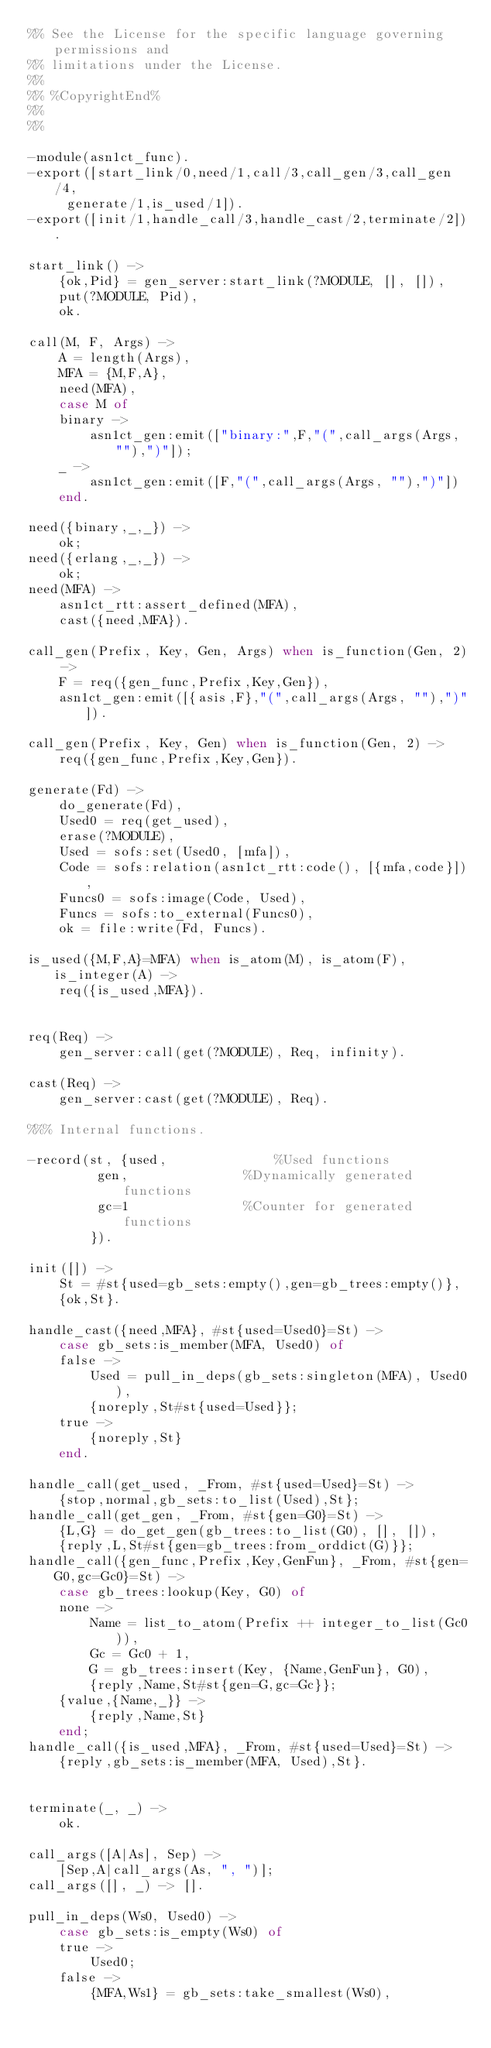Convert code to text. <code><loc_0><loc_0><loc_500><loc_500><_Erlang_>%% See the License for the specific language governing permissions and
%% limitations under the License.
%%
%% %CopyrightEnd%
%%
%%

-module(asn1ct_func).
-export([start_link/0,need/1,call/3,call_gen/3,call_gen/4,
	 generate/1,is_used/1]).
-export([init/1,handle_call/3,handle_cast/2,terminate/2]).

start_link() ->
    {ok,Pid} = gen_server:start_link(?MODULE, [], []),
    put(?MODULE, Pid),
    ok.

call(M, F, Args) ->
    A = length(Args),
    MFA = {M,F,A},
    need(MFA),
    case M of
	binary ->
	    asn1ct_gen:emit(["binary:",F,"(",call_args(Args, ""),")"]);
	_ ->
	    asn1ct_gen:emit([F,"(",call_args(Args, ""),")"])
    end.

need({binary,_,_}) ->
    ok;
need({erlang,_,_}) ->
    ok;
need(MFA) ->
    asn1ct_rtt:assert_defined(MFA),
    cast({need,MFA}).

call_gen(Prefix, Key, Gen, Args) when is_function(Gen, 2) ->
    F = req({gen_func,Prefix,Key,Gen}),
    asn1ct_gen:emit([{asis,F},"(",call_args(Args, ""),")"]).

call_gen(Prefix, Key, Gen) when is_function(Gen, 2) ->
    req({gen_func,Prefix,Key,Gen}).

generate(Fd) ->
    do_generate(Fd),
    Used0 = req(get_used),
    erase(?MODULE),
    Used = sofs:set(Used0, [mfa]),
    Code = sofs:relation(asn1ct_rtt:code(), [{mfa,code}]),
    Funcs0 = sofs:image(Code, Used),
    Funcs = sofs:to_external(Funcs0),
    ok = file:write(Fd, Funcs).

is_used({M,F,A}=MFA) when is_atom(M), is_atom(F), is_integer(A) ->
    req({is_used,MFA}).


req(Req) ->
    gen_server:call(get(?MODULE), Req, infinity).

cast(Req) ->
    gen_server:cast(get(?MODULE), Req).

%%% Internal functions.

-record(st, {used,				%Used functions
	     gen,				%Dynamically generated functions
	     gc=1				%Counter for generated functions
	    }).

init([]) ->
    St = #st{used=gb_sets:empty(),gen=gb_trees:empty()},
    {ok,St}.

handle_cast({need,MFA}, #st{used=Used0}=St) ->
    case gb_sets:is_member(MFA, Used0) of
	false ->
	    Used = pull_in_deps(gb_sets:singleton(MFA), Used0),
	    {noreply,St#st{used=Used}};
	true ->
	    {noreply,St}
    end.

handle_call(get_used, _From, #st{used=Used}=St) ->
    {stop,normal,gb_sets:to_list(Used),St};
handle_call(get_gen, _From, #st{gen=G0}=St) ->
    {L,G} = do_get_gen(gb_trees:to_list(G0), [], []),
    {reply,L,St#st{gen=gb_trees:from_orddict(G)}};
handle_call({gen_func,Prefix,Key,GenFun}, _From, #st{gen=G0,gc=Gc0}=St) ->
    case gb_trees:lookup(Key, G0) of
	none ->
	    Name = list_to_atom(Prefix ++ integer_to_list(Gc0)),
	    Gc = Gc0 + 1,
	    G = gb_trees:insert(Key, {Name,GenFun}, G0),
	    {reply,Name,St#st{gen=G,gc=Gc}};
	{value,{Name,_}} ->
	    {reply,Name,St}
    end;
handle_call({is_used,MFA}, _From, #st{used=Used}=St) ->
    {reply,gb_sets:is_member(MFA, Used),St}.


terminate(_, _) ->
    ok.

call_args([A|As], Sep) ->
    [Sep,A|call_args(As, ", ")];
call_args([], _) -> [].

pull_in_deps(Ws0, Used0) ->
    case gb_sets:is_empty(Ws0) of
	true ->
	    Used0;
	false ->
	    {MFA,Ws1} = gb_sets:take_smallest(Ws0),</code> 